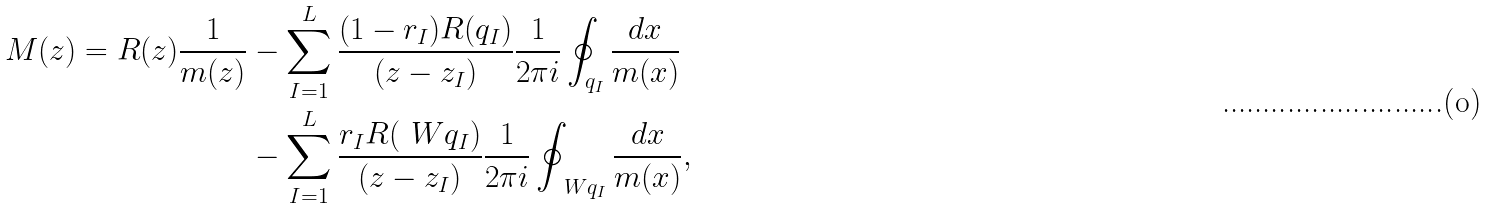Convert formula to latex. <formula><loc_0><loc_0><loc_500><loc_500>M ( z ) = R ( z ) \frac { 1 } { m ( z ) } & - \sum _ { I = 1 } ^ { L } \frac { ( 1 - r _ { I } ) R ( q _ { I } ) } { ( z - z _ { I } ) } \frac { 1 } { 2 \pi i } \oint _ { q _ { I } } \frac { d x } { m ( x ) } \\ & - \sum _ { I = 1 } ^ { L } \frac { r _ { I } R ( \ W q _ { I } ) } { ( z - z _ { I } ) } \frac { 1 } { 2 \pi i } \oint _ { \ W q _ { I } } \frac { d x } { m ( x ) } ,</formula> 